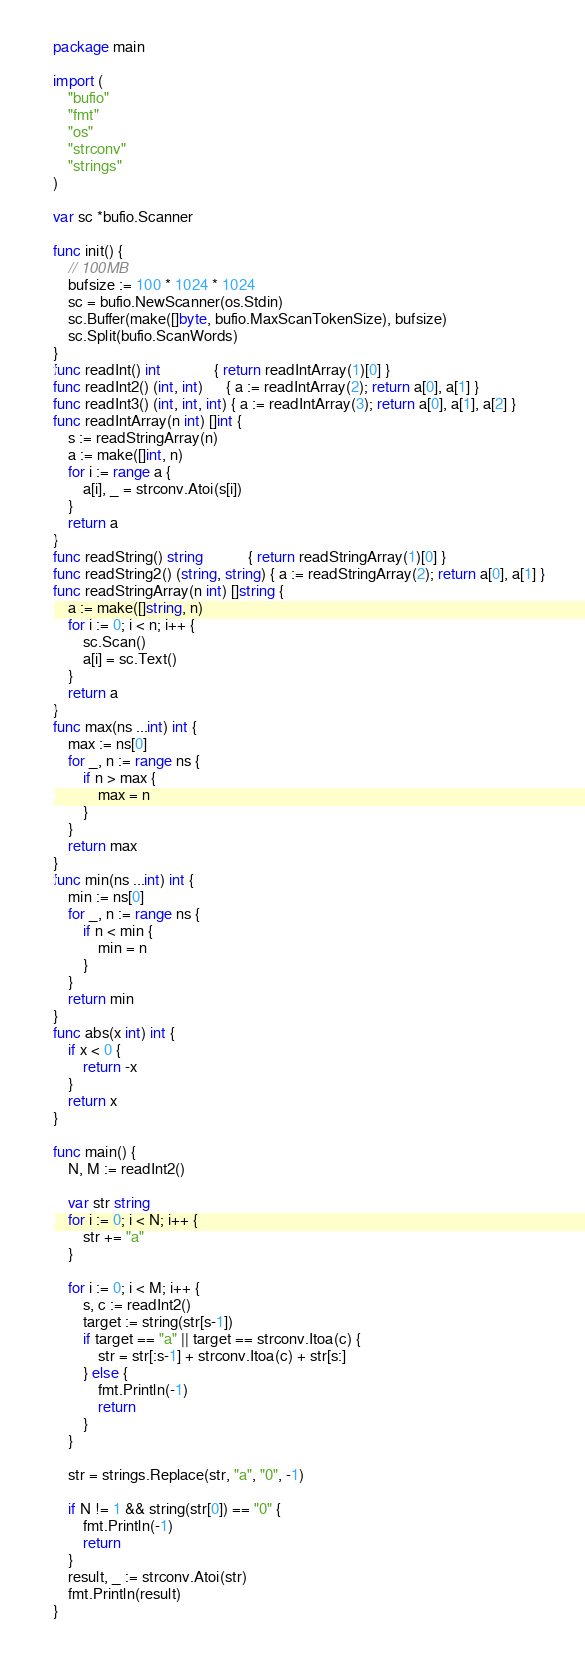<code> <loc_0><loc_0><loc_500><loc_500><_Go_>package main

import (
	"bufio"
	"fmt"
	"os"
	"strconv"
	"strings"
)

var sc *bufio.Scanner

func init() {
	// 100MB
	bufsize := 100 * 1024 * 1024
	sc = bufio.NewScanner(os.Stdin)
	sc.Buffer(make([]byte, bufio.MaxScanTokenSize), bufsize)
	sc.Split(bufio.ScanWords)
}
func readInt() int              { return readIntArray(1)[0] }
func readInt2() (int, int)      { a := readIntArray(2); return a[0], a[1] }
func readInt3() (int, int, int) { a := readIntArray(3); return a[0], a[1], a[2] }
func readIntArray(n int) []int {
	s := readStringArray(n)
	a := make([]int, n)
	for i := range a {
		a[i], _ = strconv.Atoi(s[i])
	}
	return a
}
func readString() string            { return readStringArray(1)[0] }
func readString2() (string, string) { a := readStringArray(2); return a[0], a[1] }
func readStringArray(n int) []string {
	a := make([]string, n)
	for i := 0; i < n; i++ {
		sc.Scan()
		a[i] = sc.Text()
	}
	return a
}
func max(ns ...int) int {
	max := ns[0]
	for _, n := range ns {
		if n > max {
			max = n
		}
	}
	return max
}
func min(ns ...int) int {
	min := ns[0]
	for _, n := range ns {
		if n < min {
			min = n
		}
	}
	return min
}
func abs(x int) int {
	if x < 0 {
		return -x
	}
	return x
}

func main() {
	N, M := readInt2()

	var str string
	for i := 0; i < N; i++ {
		str += "a"
	}

	for i := 0; i < M; i++ {
		s, c := readInt2()
		target := string(str[s-1])
		if target == "a" || target == strconv.Itoa(c) {
			str = str[:s-1] + strconv.Itoa(c) + str[s:]
		} else {
			fmt.Println(-1)
			return
		}
	}

	str = strings.Replace(str, "a", "0", -1)

	if N != 1 && string(str[0]) == "0" {
		fmt.Println(-1)
		return
	}
	result, _ := strconv.Atoi(str)
	fmt.Println(result)
}
</code> 